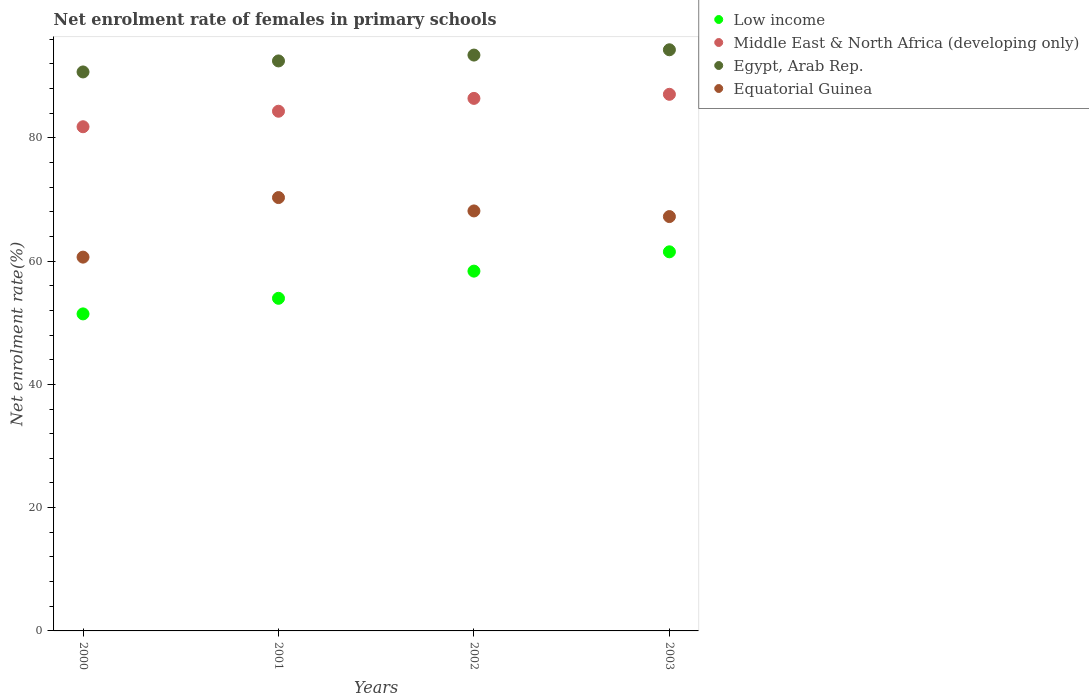Is the number of dotlines equal to the number of legend labels?
Provide a succinct answer. Yes. What is the net enrolment rate of females in primary schools in Low income in 2003?
Offer a terse response. 61.5. Across all years, what is the maximum net enrolment rate of females in primary schools in Low income?
Make the answer very short. 61.5. Across all years, what is the minimum net enrolment rate of females in primary schools in Low income?
Offer a terse response. 51.43. In which year was the net enrolment rate of females in primary schools in Low income minimum?
Offer a terse response. 2000. What is the total net enrolment rate of females in primary schools in Egypt, Arab Rep. in the graph?
Your answer should be compact. 370.83. What is the difference between the net enrolment rate of females in primary schools in Egypt, Arab Rep. in 2000 and that in 2002?
Provide a short and direct response. -2.74. What is the difference between the net enrolment rate of females in primary schools in Equatorial Guinea in 2003 and the net enrolment rate of females in primary schools in Low income in 2001?
Your answer should be very brief. 13.26. What is the average net enrolment rate of females in primary schools in Equatorial Guinea per year?
Provide a short and direct response. 66.57. In the year 2001, what is the difference between the net enrolment rate of females in primary schools in Egypt, Arab Rep. and net enrolment rate of females in primary schools in Equatorial Guinea?
Ensure brevity in your answer.  22.17. What is the ratio of the net enrolment rate of females in primary schools in Middle East & North Africa (developing only) in 2000 to that in 2002?
Provide a short and direct response. 0.95. What is the difference between the highest and the second highest net enrolment rate of females in primary schools in Low income?
Your response must be concise. 3.13. What is the difference between the highest and the lowest net enrolment rate of females in primary schools in Equatorial Guinea?
Give a very brief answer. 9.66. Is it the case that in every year, the sum of the net enrolment rate of females in primary schools in Middle East & North Africa (developing only) and net enrolment rate of females in primary schools in Egypt, Arab Rep.  is greater than the net enrolment rate of females in primary schools in Low income?
Make the answer very short. Yes. Does the net enrolment rate of females in primary schools in Middle East & North Africa (developing only) monotonically increase over the years?
Provide a succinct answer. Yes. What is the difference between two consecutive major ticks on the Y-axis?
Offer a terse response. 20. Does the graph contain any zero values?
Your response must be concise. No. Where does the legend appear in the graph?
Ensure brevity in your answer.  Top right. How are the legend labels stacked?
Offer a very short reply. Vertical. What is the title of the graph?
Provide a short and direct response. Net enrolment rate of females in primary schools. What is the label or title of the Y-axis?
Ensure brevity in your answer.  Net enrolment rate(%). What is the Net enrolment rate(%) of Low income in 2000?
Provide a succinct answer. 51.43. What is the Net enrolment rate(%) of Middle East & North Africa (developing only) in 2000?
Your answer should be compact. 81.79. What is the Net enrolment rate(%) in Egypt, Arab Rep. in 2000?
Make the answer very short. 90.68. What is the Net enrolment rate(%) in Equatorial Guinea in 2000?
Provide a succinct answer. 60.64. What is the Net enrolment rate(%) of Low income in 2001?
Your response must be concise. 53.96. What is the Net enrolment rate(%) of Middle East & North Africa (developing only) in 2001?
Ensure brevity in your answer.  84.31. What is the Net enrolment rate(%) of Egypt, Arab Rep. in 2001?
Your response must be concise. 92.46. What is the Net enrolment rate(%) in Equatorial Guinea in 2001?
Make the answer very short. 70.3. What is the Net enrolment rate(%) in Low income in 2002?
Offer a very short reply. 58.37. What is the Net enrolment rate(%) in Middle East & North Africa (developing only) in 2002?
Ensure brevity in your answer.  86.39. What is the Net enrolment rate(%) in Egypt, Arab Rep. in 2002?
Provide a short and direct response. 93.42. What is the Net enrolment rate(%) in Equatorial Guinea in 2002?
Offer a very short reply. 68.13. What is the Net enrolment rate(%) of Low income in 2003?
Make the answer very short. 61.5. What is the Net enrolment rate(%) in Middle East & North Africa (developing only) in 2003?
Your answer should be compact. 87.05. What is the Net enrolment rate(%) of Egypt, Arab Rep. in 2003?
Ensure brevity in your answer.  94.27. What is the Net enrolment rate(%) in Equatorial Guinea in 2003?
Ensure brevity in your answer.  67.22. Across all years, what is the maximum Net enrolment rate(%) of Low income?
Provide a succinct answer. 61.5. Across all years, what is the maximum Net enrolment rate(%) of Middle East & North Africa (developing only)?
Your answer should be very brief. 87.05. Across all years, what is the maximum Net enrolment rate(%) in Egypt, Arab Rep.?
Offer a terse response. 94.27. Across all years, what is the maximum Net enrolment rate(%) in Equatorial Guinea?
Ensure brevity in your answer.  70.3. Across all years, what is the minimum Net enrolment rate(%) of Low income?
Offer a terse response. 51.43. Across all years, what is the minimum Net enrolment rate(%) of Middle East & North Africa (developing only)?
Make the answer very short. 81.79. Across all years, what is the minimum Net enrolment rate(%) of Egypt, Arab Rep.?
Make the answer very short. 90.68. Across all years, what is the minimum Net enrolment rate(%) of Equatorial Guinea?
Your response must be concise. 60.64. What is the total Net enrolment rate(%) of Low income in the graph?
Keep it short and to the point. 225.25. What is the total Net enrolment rate(%) in Middle East & North Africa (developing only) in the graph?
Ensure brevity in your answer.  339.53. What is the total Net enrolment rate(%) in Egypt, Arab Rep. in the graph?
Provide a short and direct response. 370.83. What is the total Net enrolment rate(%) in Equatorial Guinea in the graph?
Ensure brevity in your answer.  266.28. What is the difference between the Net enrolment rate(%) in Low income in 2000 and that in 2001?
Your response must be concise. -2.53. What is the difference between the Net enrolment rate(%) of Middle East & North Africa (developing only) in 2000 and that in 2001?
Make the answer very short. -2.52. What is the difference between the Net enrolment rate(%) of Egypt, Arab Rep. in 2000 and that in 2001?
Give a very brief answer. -1.79. What is the difference between the Net enrolment rate(%) in Equatorial Guinea in 2000 and that in 2001?
Your answer should be compact. -9.66. What is the difference between the Net enrolment rate(%) in Low income in 2000 and that in 2002?
Give a very brief answer. -6.94. What is the difference between the Net enrolment rate(%) in Middle East & North Africa (developing only) in 2000 and that in 2002?
Offer a terse response. -4.6. What is the difference between the Net enrolment rate(%) in Egypt, Arab Rep. in 2000 and that in 2002?
Offer a terse response. -2.74. What is the difference between the Net enrolment rate(%) of Equatorial Guinea in 2000 and that in 2002?
Make the answer very short. -7.49. What is the difference between the Net enrolment rate(%) of Low income in 2000 and that in 2003?
Provide a short and direct response. -10.07. What is the difference between the Net enrolment rate(%) of Middle East & North Africa (developing only) in 2000 and that in 2003?
Offer a very short reply. -5.26. What is the difference between the Net enrolment rate(%) in Egypt, Arab Rep. in 2000 and that in 2003?
Provide a short and direct response. -3.6. What is the difference between the Net enrolment rate(%) of Equatorial Guinea in 2000 and that in 2003?
Provide a succinct answer. -6.58. What is the difference between the Net enrolment rate(%) in Low income in 2001 and that in 2002?
Your answer should be very brief. -4.41. What is the difference between the Net enrolment rate(%) in Middle East & North Africa (developing only) in 2001 and that in 2002?
Keep it short and to the point. -2.08. What is the difference between the Net enrolment rate(%) of Egypt, Arab Rep. in 2001 and that in 2002?
Provide a short and direct response. -0.95. What is the difference between the Net enrolment rate(%) in Equatorial Guinea in 2001 and that in 2002?
Your answer should be very brief. 2.17. What is the difference between the Net enrolment rate(%) of Low income in 2001 and that in 2003?
Ensure brevity in your answer.  -7.54. What is the difference between the Net enrolment rate(%) in Middle East & North Africa (developing only) in 2001 and that in 2003?
Offer a very short reply. -2.75. What is the difference between the Net enrolment rate(%) of Egypt, Arab Rep. in 2001 and that in 2003?
Ensure brevity in your answer.  -1.81. What is the difference between the Net enrolment rate(%) of Equatorial Guinea in 2001 and that in 2003?
Give a very brief answer. 3.08. What is the difference between the Net enrolment rate(%) in Low income in 2002 and that in 2003?
Keep it short and to the point. -3.13. What is the difference between the Net enrolment rate(%) of Middle East & North Africa (developing only) in 2002 and that in 2003?
Your response must be concise. -0.66. What is the difference between the Net enrolment rate(%) of Egypt, Arab Rep. in 2002 and that in 2003?
Your answer should be compact. -0.86. What is the difference between the Net enrolment rate(%) of Equatorial Guinea in 2002 and that in 2003?
Ensure brevity in your answer.  0.91. What is the difference between the Net enrolment rate(%) of Low income in 2000 and the Net enrolment rate(%) of Middle East & North Africa (developing only) in 2001?
Provide a succinct answer. -32.88. What is the difference between the Net enrolment rate(%) in Low income in 2000 and the Net enrolment rate(%) in Egypt, Arab Rep. in 2001?
Keep it short and to the point. -41.04. What is the difference between the Net enrolment rate(%) in Low income in 2000 and the Net enrolment rate(%) in Equatorial Guinea in 2001?
Provide a short and direct response. -18.87. What is the difference between the Net enrolment rate(%) of Middle East & North Africa (developing only) in 2000 and the Net enrolment rate(%) of Egypt, Arab Rep. in 2001?
Make the answer very short. -10.68. What is the difference between the Net enrolment rate(%) in Middle East & North Africa (developing only) in 2000 and the Net enrolment rate(%) in Equatorial Guinea in 2001?
Ensure brevity in your answer.  11.49. What is the difference between the Net enrolment rate(%) in Egypt, Arab Rep. in 2000 and the Net enrolment rate(%) in Equatorial Guinea in 2001?
Provide a succinct answer. 20.38. What is the difference between the Net enrolment rate(%) in Low income in 2000 and the Net enrolment rate(%) in Middle East & North Africa (developing only) in 2002?
Offer a very short reply. -34.96. What is the difference between the Net enrolment rate(%) in Low income in 2000 and the Net enrolment rate(%) in Egypt, Arab Rep. in 2002?
Your answer should be compact. -41.99. What is the difference between the Net enrolment rate(%) in Low income in 2000 and the Net enrolment rate(%) in Equatorial Guinea in 2002?
Offer a terse response. -16.7. What is the difference between the Net enrolment rate(%) in Middle East & North Africa (developing only) in 2000 and the Net enrolment rate(%) in Egypt, Arab Rep. in 2002?
Ensure brevity in your answer.  -11.63. What is the difference between the Net enrolment rate(%) in Middle East & North Africa (developing only) in 2000 and the Net enrolment rate(%) in Equatorial Guinea in 2002?
Offer a very short reply. 13.66. What is the difference between the Net enrolment rate(%) in Egypt, Arab Rep. in 2000 and the Net enrolment rate(%) in Equatorial Guinea in 2002?
Give a very brief answer. 22.55. What is the difference between the Net enrolment rate(%) of Low income in 2000 and the Net enrolment rate(%) of Middle East & North Africa (developing only) in 2003?
Offer a very short reply. -35.62. What is the difference between the Net enrolment rate(%) in Low income in 2000 and the Net enrolment rate(%) in Egypt, Arab Rep. in 2003?
Keep it short and to the point. -42.84. What is the difference between the Net enrolment rate(%) in Low income in 2000 and the Net enrolment rate(%) in Equatorial Guinea in 2003?
Your response must be concise. -15.79. What is the difference between the Net enrolment rate(%) of Middle East & North Africa (developing only) in 2000 and the Net enrolment rate(%) of Egypt, Arab Rep. in 2003?
Ensure brevity in your answer.  -12.49. What is the difference between the Net enrolment rate(%) of Middle East & North Africa (developing only) in 2000 and the Net enrolment rate(%) of Equatorial Guinea in 2003?
Your response must be concise. 14.57. What is the difference between the Net enrolment rate(%) of Egypt, Arab Rep. in 2000 and the Net enrolment rate(%) of Equatorial Guinea in 2003?
Provide a short and direct response. 23.46. What is the difference between the Net enrolment rate(%) in Low income in 2001 and the Net enrolment rate(%) in Middle East & North Africa (developing only) in 2002?
Your answer should be compact. -32.43. What is the difference between the Net enrolment rate(%) in Low income in 2001 and the Net enrolment rate(%) in Egypt, Arab Rep. in 2002?
Give a very brief answer. -39.46. What is the difference between the Net enrolment rate(%) in Low income in 2001 and the Net enrolment rate(%) in Equatorial Guinea in 2002?
Keep it short and to the point. -14.17. What is the difference between the Net enrolment rate(%) of Middle East & North Africa (developing only) in 2001 and the Net enrolment rate(%) of Egypt, Arab Rep. in 2002?
Your answer should be compact. -9.11. What is the difference between the Net enrolment rate(%) of Middle East & North Africa (developing only) in 2001 and the Net enrolment rate(%) of Equatorial Guinea in 2002?
Ensure brevity in your answer.  16.17. What is the difference between the Net enrolment rate(%) of Egypt, Arab Rep. in 2001 and the Net enrolment rate(%) of Equatorial Guinea in 2002?
Make the answer very short. 24.33. What is the difference between the Net enrolment rate(%) in Low income in 2001 and the Net enrolment rate(%) in Middle East & North Africa (developing only) in 2003?
Provide a succinct answer. -33.09. What is the difference between the Net enrolment rate(%) in Low income in 2001 and the Net enrolment rate(%) in Egypt, Arab Rep. in 2003?
Provide a short and direct response. -40.32. What is the difference between the Net enrolment rate(%) of Low income in 2001 and the Net enrolment rate(%) of Equatorial Guinea in 2003?
Your response must be concise. -13.26. What is the difference between the Net enrolment rate(%) of Middle East & North Africa (developing only) in 2001 and the Net enrolment rate(%) of Egypt, Arab Rep. in 2003?
Provide a short and direct response. -9.97. What is the difference between the Net enrolment rate(%) in Middle East & North Africa (developing only) in 2001 and the Net enrolment rate(%) in Equatorial Guinea in 2003?
Keep it short and to the point. 17.09. What is the difference between the Net enrolment rate(%) in Egypt, Arab Rep. in 2001 and the Net enrolment rate(%) in Equatorial Guinea in 2003?
Offer a very short reply. 25.25. What is the difference between the Net enrolment rate(%) in Low income in 2002 and the Net enrolment rate(%) in Middle East & North Africa (developing only) in 2003?
Keep it short and to the point. -28.69. What is the difference between the Net enrolment rate(%) in Low income in 2002 and the Net enrolment rate(%) in Egypt, Arab Rep. in 2003?
Give a very brief answer. -35.91. What is the difference between the Net enrolment rate(%) in Low income in 2002 and the Net enrolment rate(%) in Equatorial Guinea in 2003?
Provide a short and direct response. -8.85. What is the difference between the Net enrolment rate(%) of Middle East & North Africa (developing only) in 2002 and the Net enrolment rate(%) of Egypt, Arab Rep. in 2003?
Your answer should be compact. -7.89. What is the difference between the Net enrolment rate(%) of Middle East & North Africa (developing only) in 2002 and the Net enrolment rate(%) of Equatorial Guinea in 2003?
Offer a very short reply. 19.17. What is the difference between the Net enrolment rate(%) in Egypt, Arab Rep. in 2002 and the Net enrolment rate(%) in Equatorial Guinea in 2003?
Provide a succinct answer. 26.2. What is the average Net enrolment rate(%) in Low income per year?
Provide a succinct answer. 56.31. What is the average Net enrolment rate(%) in Middle East & North Africa (developing only) per year?
Your answer should be compact. 84.88. What is the average Net enrolment rate(%) in Egypt, Arab Rep. per year?
Your answer should be very brief. 92.71. What is the average Net enrolment rate(%) of Equatorial Guinea per year?
Offer a very short reply. 66.57. In the year 2000, what is the difference between the Net enrolment rate(%) in Low income and Net enrolment rate(%) in Middle East & North Africa (developing only)?
Your answer should be very brief. -30.36. In the year 2000, what is the difference between the Net enrolment rate(%) of Low income and Net enrolment rate(%) of Egypt, Arab Rep.?
Offer a terse response. -39.25. In the year 2000, what is the difference between the Net enrolment rate(%) of Low income and Net enrolment rate(%) of Equatorial Guinea?
Your answer should be very brief. -9.21. In the year 2000, what is the difference between the Net enrolment rate(%) of Middle East & North Africa (developing only) and Net enrolment rate(%) of Egypt, Arab Rep.?
Make the answer very short. -8.89. In the year 2000, what is the difference between the Net enrolment rate(%) in Middle East & North Africa (developing only) and Net enrolment rate(%) in Equatorial Guinea?
Give a very brief answer. 21.15. In the year 2000, what is the difference between the Net enrolment rate(%) of Egypt, Arab Rep. and Net enrolment rate(%) of Equatorial Guinea?
Your response must be concise. 30.04. In the year 2001, what is the difference between the Net enrolment rate(%) of Low income and Net enrolment rate(%) of Middle East & North Africa (developing only)?
Your answer should be very brief. -30.35. In the year 2001, what is the difference between the Net enrolment rate(%) in Low income and Net enrolment rate(%) in Egypt, Arab Rep.?
Make the answer very short. -38.51. In the year 2001, what is the difference between the Net enrolment rate(%) of Low income and Net enrolment rate(%) of Equatorial Guinea?
Offer a terse response. -16.34. In the year 2001, what is the difference between the Net enrolment rate(%) of Middle East & North Africa (developing only) and Net enrolment rate(%) of Egypt, Arab Rep.?
Your response must be concise. -8.16. In the year 2001, what is the difference between the Net enrolment rate(%) in Middle East & North Africa (developing only) and Net enrolment rate(%) in Equatorial Guinea?
Offer a terse response. 14.01. In the year 2001, what is the difference between the Net enrolment rate(%) in Egypt, Arab Rep. and Net enrolment rate(%) in Equatorial Guinea?
Ensure brevity in your answer.  22.17. In the year 2002, what is the difference between the Net enrolment rate(%) of Low income and Net enrolment rate(%) of Middle East & North Africa (developing only)?
Make the answer very short. -28.02. In the year 2002, what is the difference between the Net enrolment rate(%) in Low income and Net enrolment rate(%) in Egypt, Arab Rep.?
Your answer should be compact. -35.05. In the year 2002, what is the difference between the Net enrolment rate(%) in Low income and Net enrolment rate(%) in Equatorial Guinea?
Your response must be concise. -9.77. In the year 2002, what is the difference between the Net enrolment rate(%) of Middle East & North Africa (developing only) and Net enrolment rate(%) of Egypt, Arab Rep.?
Offer a very short reply. -7.03. In the year 2002, what is the difference between the Net enrolment rate(%) in Middle East & North Africa (developing only) and Net enrolment rate(%) in Equatorial Guinea?
Your response must be concise. 18.26. In the year 2002, what is the difference between the Net enrolment rate(%) in Egypt, Arab Rep. and Net enrolment rate(%) in Equatorial Guinea?
Keep it short and to the point. 25.28. In the year 2003, what is the difference between the Net enrolment rate(%) of Low income and Net enrolment rate(%) of Middle East & North Africa (developing only)?
Provide a succinct answer. -25.55. In the year 2003, what is the difference between the Net enrolment rate(%) in Low income and Net enrolment rate(%) in Egypt, Arab Rep.?
Ensure brevity in your answer.  -32.78. In the year 2003, what is the difference between the Net enrolment rate(%) in Low income and Net enrolment rate(%) in Equatorial Guinea?
Your answer should be very brief. -5.72. In the year 2003, what is the difference between the Net enrolment rate(%) in Middle East & North Africa (developing only) and Net enrolment rate(%) in Egypt, Arab Rep.?
Your answer should be compact. -7.22. In the year 2003, what is the difference between the Net enrolment rate(%) in Middle East & North Africa (developing only) and Net enrolment rate(%) in Equatorial Guinea?
Your response must be concise. 19.83. In the year 2003, what is the difference between the Net enrolment rate(%) in Egypt, Arab Rep. and Net enrolment rate(%) in Equatorial Guinea?
Keep it short and to the point. 27.06. What is the ratio of the Net enrolment rate(%) in Low income in 2000 to that in 2001?
Offer a terse response. 0.95. What is the ratio of the Net enrolment rate(%) in Middle East & North Africa (developing only) in 2000 to that in 2001?
Offer a very short reply. 0.97. What is the ratio of the Net enrolment rate(%) of Egypt, Arab Rep. in 2000 to that in 2001?
Keep it short and to the point. 0.98. What is the ratio of the Net enrolment rate(%) of Equatorial Guinea in 2000 to that in 2001?
Offer a very short reply. 0.86. What is the ratio of the Net enrolment rate(%) of Low income in 2000 to that in 2002?
Your answer should be compact. 0.88. What is the ratio of the Net enrolment rate(%) of Middle East & North Africa (developing only) in 2000 to that in 2002?
Make the answer very short. 0.95. What is the ratio of the Net enrolment rate(%) in Egypt, Arab Rep. in 2000 to that in 2002?
Provide a succinct answer. 0.97. What is the ratio of the Net enrolment rate(%) in Equatorial Guinea in 2000 to that in 2002?
Offer a very short reply. 0.89. What is the ratio of the Net enrolment rate(%) of Low income in 2000 to that in 2003?
Make the answer very short. 0.84. What is the ratio of the Net enrolment rate(%) in Middle East & North Africa (developing only) in 2000 to that in 2003?
Make the answer very short. 0.94. What is the ratio of the Net enrolment rate(%) of Egypt, Arab Rep. in 2000 to that in 2003?
Provide a short and direct response. 0.96. What is the ratio of the Net enrolment rate(%) of Equatorial Guinea in 2000 to that in 2003?
Your response must be concise. 0.9. What is the ratio of the Net enrolment rate(%) in Low income in 2001 to that in 2002?
Make the answer very short. 0.92. What is the ratio of the Net enrolment rate(%) of Middle East & North Africa (developing only) in 2001 to that in 2002?
Offer a very short reply. 0.98. What is the ratio of the Net enrolment rate(%) in Egypt, Arab Rep. in 2001 to that in 2002?
Provide a short and direct response. 0.99. What is the ratio of the Net enrolment rate(%) of Equatorial Guinea in 2001 to that in 2002?
Offer a very short reply. 1.03. What is the ratio of the Net enrolment rate(%) of Low income in 2001 to that in 2003?
Your answer should be very brief. 0.88. What is the ratio of the Net enrolment rate(%) of Middle East & North Africa (developing only) in 2001 to that in 2003?
Your answer should be compact. 0.97. What is the ratio of the Net enrolment rate(%) in Egypt, Arab Rep. in 2001 to that in 2003?
Give a very brief answer. 0.98. What is the ratio of the Net enrolment rate(%) in Equatorial Guinea in 2001 to that in 2003?
Ensure brevity in your answer.  1.05. What is the ratio of the Net enrolment rate(%) of Low income in 2002 to that in 2003?
Your answer should be very brief. 0.95. What is the ratio of the Net enrolment rate(%) of Middle East & North Africa (developing only) in 2002 to that in 2003?
Provide a short and direct response. 0.99. What is the ratio of the Net enrolment rate(%) in Egypt, Arab Rep. in 2002 to that in 2003?
Give a very brief answer. 0.99. What is the ratio of the Net enrolment rate(%) of Equatorial Guinea in 2002 to that in 2003?
Your response must be concise. 1.01. What is the difference between the highest and the second highest Net enrolment rate(%) in Low income?
Keep it short and to the point. 3.13. What is the difference between the highest and the second highest Net enrolment rate(%) in Middle East & North Africa (developing only)?
Ensure brevity in your answer.  0.66. What is the difference between the highest and the second highest Net enrolment rate(%) in Egypt, Arab Rep.?
Keep it short and to the point. 0.86. What is the difference between the highest and the second highest Net enrolment rate(%) of Equatorial Guinea?
Make the answer very short. 2.17. What is the difference between the highest and the lowest Net enrolment rate(%) of Low income?
Provide a succinct answer. 10.07. What is the difference between the highest and the lowest Net enrolment rate(%) in Middle East & North Africa (developing only)?
Give a very brief answer. 5.26. What is the difference between the highest and the lowest Net enrolment rate(%) in Egypt, Arab Rep.?
Ensure brevity in your answer.  3.6. What is the difference between the highest and the lowest Net enrolment rate(%) of Equatorial Guinea?
Provide a short and direct response. 9.66. 